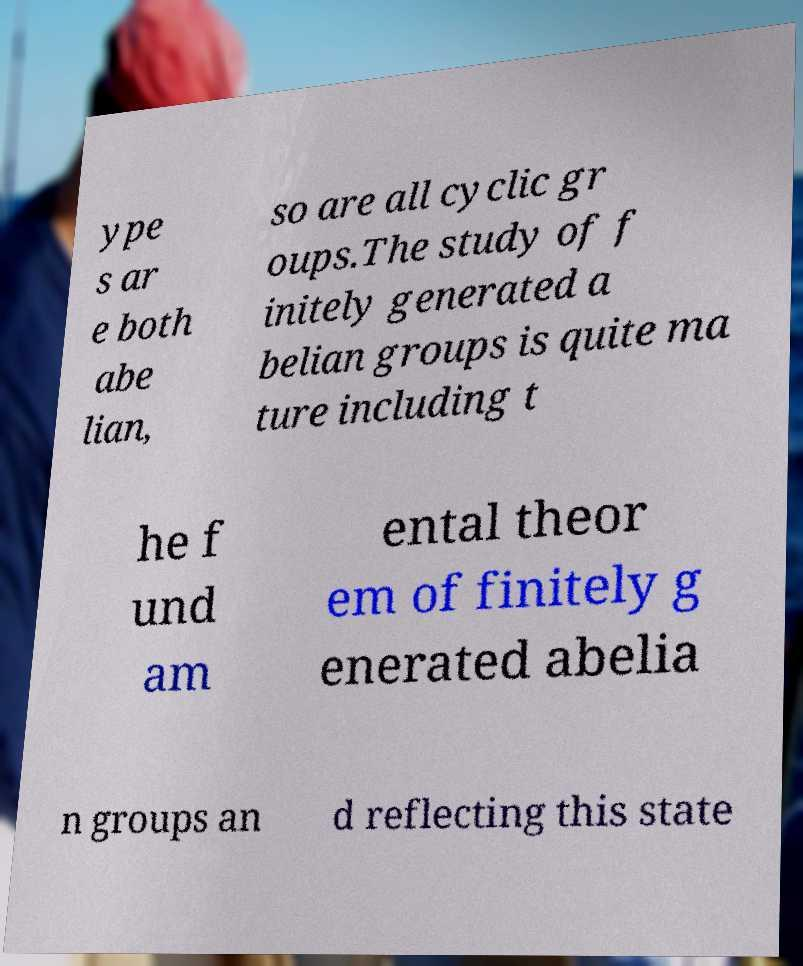Can you read and provide the text displayed in the image?This photo seems to have some interesting text. Can you extract and type it out for me? ype s ar e both abe lian, so are all cyclic gr oups.The study of f initely generated a belian groups is quite ma ture including t he f und am ental theor em of finitely g enerated abelia n groups an d reflecting this state 